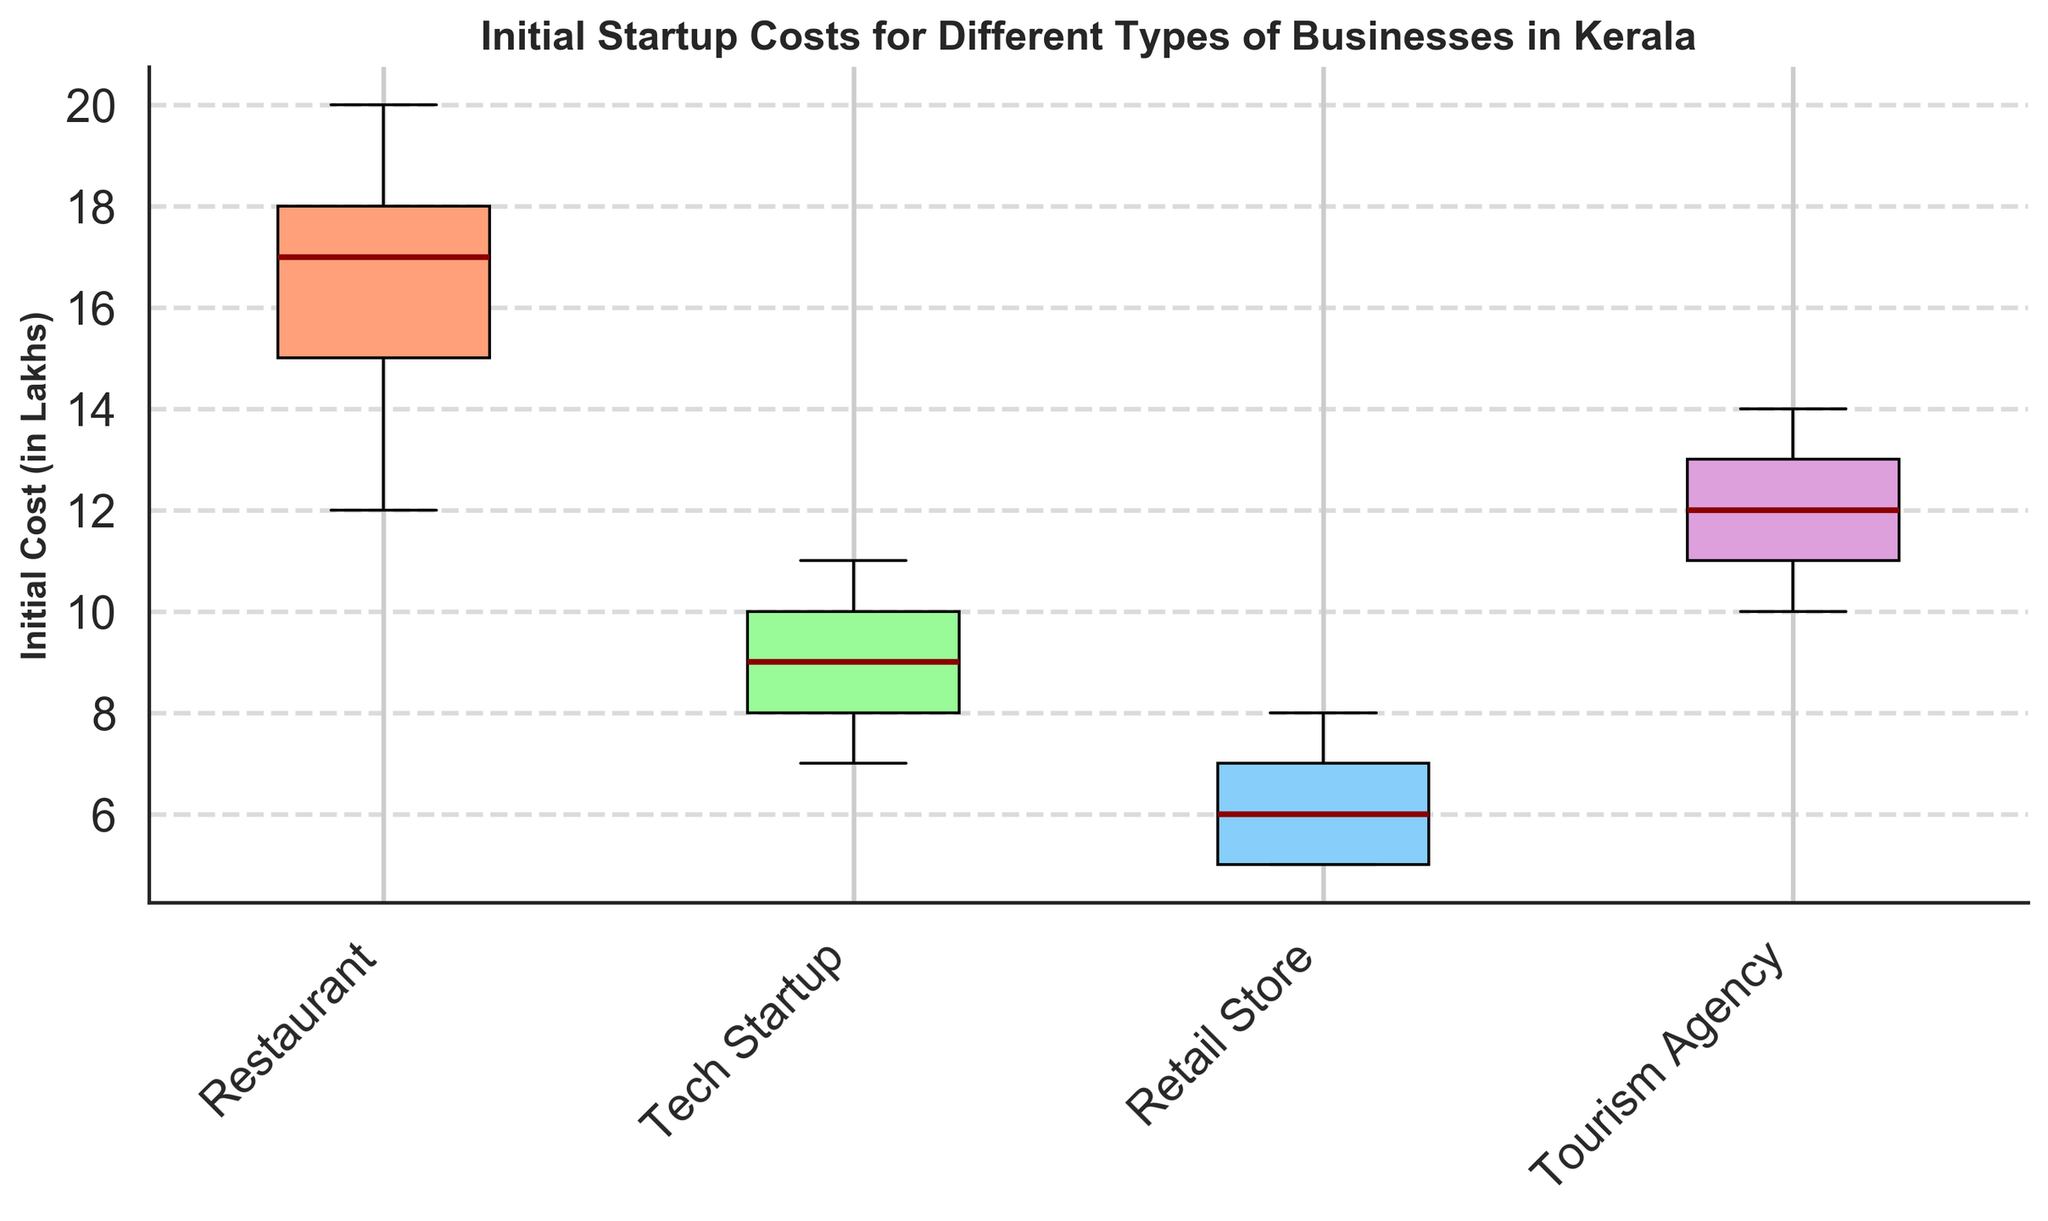What is the title of the figure? The title is displayed at the top of the figure and directly describes what the plot is about.
Answer: Initial Startup Costs for Different Types of Businesses in Kerala What are the four types of businesses displayed in the box plot? The labels on the x-axis represent the different types of businesses.
Answer: Restaurant, Tech Startup, Retail Store, Tourism Agency Which business type has the highest median initial startup cost? The median is indicated by the dark red line within each box. The highest median line belongs to the Restaurant business type.
Answer: Restaurant Which business type has the lowest range of initial startup costs? The range in a box plot is indicated by the distance between the bottom and top of the box. The Tech Startup box has the smallest vertical distance.
Answer: Tech Startup What is the median initial startup cost for Tourism Agencies? Locate the dark red line within the Tourism Agency box; it is situated at the 12 Lakh mark.
Answer: 12 Lakhs How does the interquartile range (IQR) of Retail Stores compare with that of Tourism Agencies? The IQR is the distance between the bottom (25th percentile) and top (75th percentile) of the box. By comparing the height of the boxes, the IQR of Retail Stores (from 5 to 7 Lakhs) is smaller compared to that of Tourism Agencies (from 11 to 13 Lakhs).
Answer: Retail Store has a smaller IQR What is the maximum observed initial startup cost for Tech Startups? The upper whisker and any outliers (indicated with red diamonds) show the maximum value. The highest point for Tech Startups is 11 Lakhs.
Answer: 11 Lakhs Which business type has the widest range of initial startup costs? The range is the difference between the highest and lowest values. Comparing the whiskers and outliers, the Restaurant business has the widest range from 12 to 20 Lakhs.
Answer: Restaurant Are there any outliers in the data for any of the business types? Outliers are typically indicated by distinct markers (in this case, red diamonds). There are no outliers marked in any of the categories.
Answer: No 